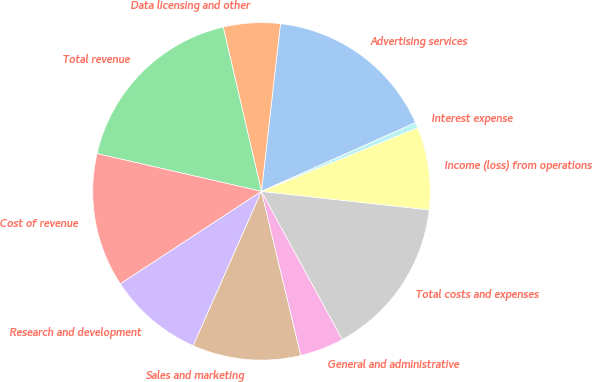<chart> <loc_0><loc_0><loc_500><loc_500><pie_chart><fcel>Advertising services<fcel>Data licensing and other<fcel>Total revenue<fcel>Cost of revenue<fcel>Research and development<fcel>Sales and marketing<fcel>General and administrative<fcel>Total costs and expenses<fcel>Income (loss) from operations<fcel>Interest expense<nl><fcel>16.53%<fcel>5.44%<fcel>17.76%<fcel>12.83%<fcel>9.14%<fcel>10.37%<fcel>4.21%<fcel>15.3%<fcel>7.91%<fcel>0.51%<nl></chart> 